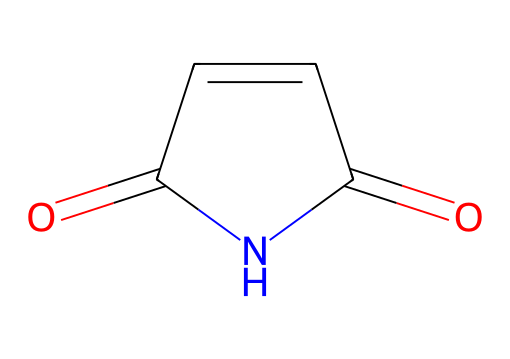What is the molecular formula of maleimide? By analyzing the structure shown in the SMILES representation, we identify the atoms present: there are 4 carbon atoms (C), 4 hydrogen atoms (H), 2 oxygen atoms (O), and 1 nitrogen atom (N). This leads to the molecular formula being C4H4N2O2.
Answer: C4H4N2O2 How many rings are present in maleimide? The SMILES representation indicates a cyclic structure due to the presence of the "C=CC" part, which forms a ring. There is only one ring structure derived from the imide functionality where carbon and nitrogen are involved.
Answer: 1 Which element is directly linked to the nitrogen atom in maleimide? Observing the structure, the nitrogen atom is part of the imide group, directly connected to a carbonyl carbon (C=O) which represents the carbonyl part of the imide structure.
Answer: carbon What type of functional groups are present in maleimide? By examining the SMILES representation, we can identify that maleimide contains both a carbonyl group (C=O) and an imide group (N-C=O), relating to its classification as an imide.
Answer: imide and carbonyl What is the degree of unsaturation in maleimide? The degree of unsaturation can be calculated based on the formula: Each ring or double bond decreases hydrogen count, indicating unsaturation. Here, there are two double bonds (C=O and C=C) in the compound. Thus, the degree is one for the ring and one for the double bond for a total of 2.
Answer: 2 How can the structure of maleimide influence its reactivity in bioconjugation? The presence of the double bond in the structure creates an electrophilic site that can react with nucleophiles, making it highly active in bioconjugation applications, which is crucial in modifying biomolecules like proteins.
Answer: it can react with nucleophiles What type of polymer can be synthesized using maleimide? Maleimide can be utilized to make thermosetting resins and can participate in the formation of various functionalized polymers, particularly those with cross-linking properties in the polymerization process.
Answer: thermosetting resins 